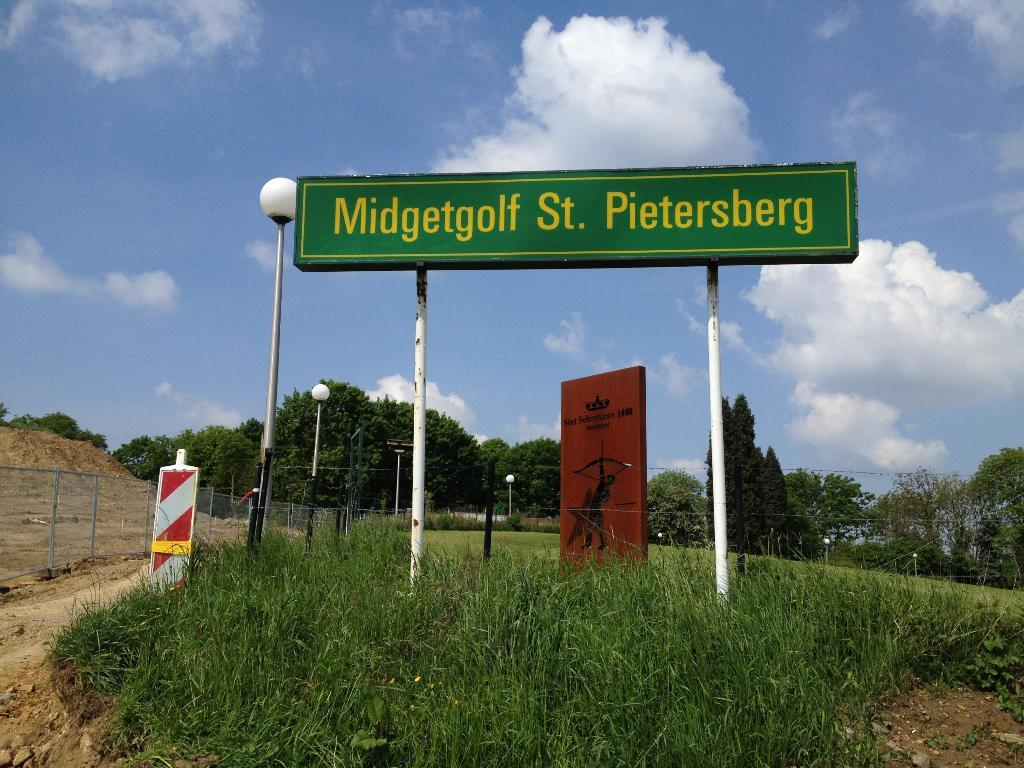<image>
Relay a brief, clear account of the picture shown. the name Pietersberg is on a green sign 